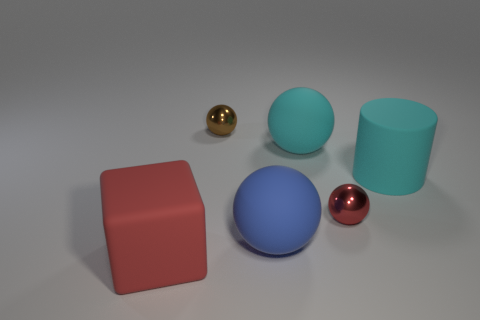Subtract 1 spheres. How many spheres are left? 3 Subtract all purple balls. Subtract all cyan blocks. How many balls are left? 4 Add 2 tiny blue rubber balls. How many objects exist? 8 Subtract all spheres. How many objects are left? 2 Add 4 red blocks. How many red blocks are left? 5 Add 2 tiny red balls. How many tiny red balls exist? 3 Subtract 0 purple balls. How many objects are left? 6 Subtract all large red rubber things. Subtract all matte balls. How many objects are left? 3 